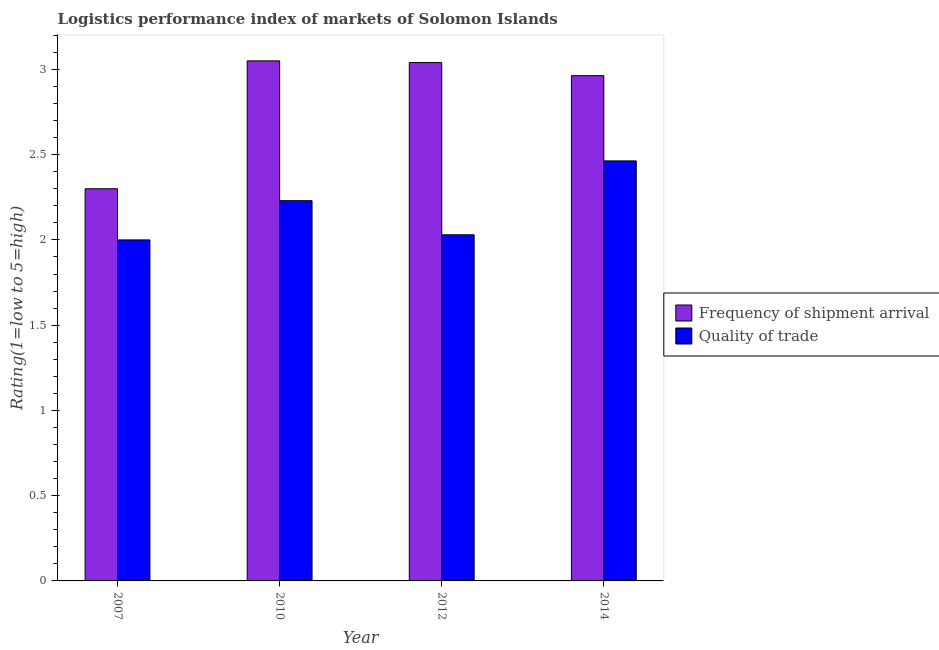How many different coloured bars are there?
Give a very brief answer. 2. Are the number of bars per tick equal to the number of legend labels?
Make the answer very short. Yes. In how many cases, is the number of bars for a given year not equal to the number of legend labels?
Offer a very short reply. 0. What is the lpi of frequency of shipment arrival in 2010?
Your answer should be very brief. 3.05. Across all years, what is the maximum lpi of frequency of shipment arrival?
Offer a terse response. 3.05. In which year was the lpi quality of trade maximum?
Your response must be concise. 2014. What is the total lpi quality of trade in the graph?
Offer a very short reply. 8.72. What is the difference between the lpi quality of trade in 2007 and that in 2010?
Offer a very short reply. -0.23. What is the difference between the lpi of frequency of shipment arrival in 2012 and the lpi quality of trade in 2014?
Your answer should be compact. 0.08. What is the average lpi of frequency of shipment arrival per year?
Ensure brevity in your answer.  2.84. What is the ratio of the lpi quality of trade in 2010 to that in 2012?
Keep it short and to the point. 1.1. Is the lpi of frequency of shipment arrival in 2007 less than that in 2012?
Offer a terse response. Yes. Is the difference between the lpi quality of trade in 2010 and 2012 greater than the difference between the lpi of frequency of shipment arrival in 2010 and 2012?
Your answer should be very brief. No. What is the difference between the highest and the second highest lpi of frequency of shipment arrival?
Make the answer very short. 0.01. What is the difference between the highest and the lowest lpi of frequency of shipment arrival?
Your response must be concise. 0.75. In how many years, is the lpi quality of trade greater than the average lpi quality of trade taken over all years?
Your response must be concise. 2. Is the sum of the lpi quality of trade in 2007 and 2014 greater than the maximum lpi of frequency of shipment arrival across all years?
Your answer should be very brief. Yes. What does the 2nd bar from the left in 2007 represents?
Make the answer very short. Quality of trade. What does the 2nd bar from the right in 2007 represents?
Provide a succinct answer. Frequency of shipment arrival. How many bars are there?
Provide a succinct answer. 8. Are all the bars in the graph horizontal?
Offer a very short reply. No. How many years are there in the graph?
Give a very brief answer. 4. Are the values on the major ticks of Y-axis written in scientific E-notation?
Provide a succinct answer. No. Does the graph contain grids?
Offer a very short reply. No. What is the title of the graph?
Give a very brief answer. Logistics performance index of markets of Solomon Islands. Does "Under-5(female)" appear as one of the legend labels in the graph?
Offer a very short reply. No. What is the label or title of the X-axis?
Provide a short and direct response. Year. What is the label or title of the Y-axis?
Give a very brief answer. Rating(1=low to 5=high). What is the Rating(1=low to 5=high) of Frequency of shipment arrival in 2010?
Keep it short and to the point. 3.05. What is the Rating(1=low to 5=high) in Quality of trade in 2010?
Give a very brief answer. 2.23. What is the Rating(1=low to 5=high) in Frequency of shipment arrival in 2012?
Provide a short and direct response. 3.04. What is the Rating(1=low to 5=high) in Quality of trade in 2012?
Offer a terse response. 2.03. What is the Rating(1=low to 5=high) of Frequency of shipment arrival in 2014?
Provide a short and direct response. 2.96. What is the Rating(1=low to 5=high) in Quality of trade in 2014?
Keep it short and to the point. 2.46. Across all years, what is the maximum Rating(1=low to 5=high) in Frequency of shipment arrival?
Make the answer very short. 3.05. Across all years, what is the maximum Rating(1=low to 5=high) in Quality of trade?
Offer a very short reply. 2.46. Across all years, what is the minimum Rating(1=low to 5=high) in Frequency of shipment arrival?
Keep it short and to the point. 2.3. What is the total Rating(1=low to 5=high) in Frequency of shipment arrival in the graph?
Give a very brief answer. 11.35. What is the total Rating(1=low to 5=high) of Quality of trade in the graph?
Provide a short and direct response. 8.72. What is the difference between the Rating(1=low to 5=high) in Frequency of shipment arrival in 2007 and that in 2010?
Your answer should be compact. -0.75. What is the difference between the Rating(1=low to 5=high) of Quality of trade in 2007 and that in 2010?
Ensure brevity in your answer.  -0.23. What is the difference between the Rating(1=low to 5=high) of Frequency of shipment arrival in 2007 and that in 2012?
Give a very brief answer. -0.74. What is the difference between the Rating(1=low to 5=high) in Quality of trade in 2007 and that in 2012?
Provide a short and direct response. -0.03. What is the difference between the Rating(1=low to 5=high) of Frequency of shipment arrival in 2007 and that in 2014?
Provide a short and direct response. -0.66. What is the difference between the Rating(1=low to 5=high) in Quality of trade in 2007 and that in 2014?
Make the answer very short. -0.46. What is the difference between the Rating(1=low to 5=high) of Frequency of shipment arrival in 2010 and that in 2014?
Keep it short and to the point. 0.09. What is the difference between the Rating(1=low to 5=high) of Quality of trade in 2010 and that in 2014?
Your response must be concise. -0.23. What is the difference between the Rating(1=low to 5=high) in Frequency of shipment arrival in 2012 and that in 2014?
Offer a very short reply. 0.08. What is the difference between the Rating(1=low to 5=high) of Quality of trade in 2012 and that in 2014?
Provide a succinct answer. -0.43. What is the difference between the Rating(1=low to 5=high) of Frequency of shipment arrival in 2007 and the Rating(1=low to 5=high) of Quality of trade in 2010?
Your answer should be compact. 0.07. What is the difference between the Rating(1=low to 5=high) of Frequency of shipment arrival in 2007 and the Rating(1=low to 5=high) of Quality of trade in 2012?
Ensure brevity in your answer.  0.27. What is the difference between the Rating(1=low to 5=high) of Frequency of shipment arrival in 2007 and the Rating(1=low to 5=high) of Quality of trade in 2014?
Your answer should be compact. -0.16. What is the difference between the Rating(1=low to 5=high) in Frequency of shipment arrival in 2010 and the Rating(1=low to 5=high) in Quality of trade in 2014?
Provide a succinct answer. 0.59. What is the difference between the Rating(1=low to 5=high) in Frequency of shipment arrival in 2012 and the Rating(1=low to 5=high) in Quality of trade in 2014?
Offer a terse response. 0.58. What is the average Rating(1=low to 5=high) in Frequency of shipment arrival per year?
Give a very brief answer. 2.84. What is the average Rating(1=low to 5=high) of Quality of trade per year?
Your answer should be compact. 2.18. In the year 2010, what is the difference between the Rating(1=low to 5=high) of Frequency of shipment arrival and Rating(1=low to 5=high) of Quality of trade?
Your answer should be very brief. 0.82. In the year 2012, what is the difference between the Rating(1=low to 5=high) of Frequency of shipment arrival and Rating(1=low to 5=high) of Quality of trade?
Offer a terse response. 1.01. In the year 2014, what is the difference between the Rating(1=low to 5=high) of Frequency of shipment arrival and Rating(1=low to 5=high) of Quality of trade?
Offer a very short reply. 0.5. What is the ratio of the Rating(1=low to 5=high) of Frequency of shipment arrival in 2007 to that in 2010?
Ensure brevity in your answer.  0.75. What is the ratio of the Rating(1=low to 5=high) in Quality of trade in 2007 to that in 2010?
Your answer should be very brief. 0.9. What is the ratio of the Rating(1=low to 5=high) of Frequency of shipment arrival in 2007 to that in 2012?
Provide a succinct answer. 0.76. What is the ratio of the Rating(1=low to 5=high) in Quality of trade in 2007 to that in 2012?
Your response must be concise. 0.99. What is the ratio of the Rating(1=low to 5=high) of Frequency of shipment arrival in 2007 to that in 2014?
Your answer should be compact. 0.78. What is the ratio of the Rating(1=low to 5=high) of Quality of trade in 2007 to that in 2014?
Make the answer very short. 0.81. What is the ratio of the Rating(1=low to 5=high) of Quality of trade in 2010 to that in 2012?
Make the answer very short. 1.1. What is the ratio of the Rating(1=low to 5=high) in Frequency of shipment arrival in 2010 to that in 2014?
Provide a succinct answer. 1.03. What is the ratio of the Rating(1=low to 5=high) in Quality of trade in 2010 to that in 2014?
Your answer should be compact. 0.91. What is the ratio of the Rating(1=low to 5=high) of Frequency of shipment arrival in 2012 to that in 2014?
Provide a succinct answer. 1.03. What is the ratio of the Rating(1=low to 5=high) in Quality of trade in 2012 to that in 2014?
Your answer should be compact. 0.82. What is the difference between the highest and the second highest Rating(1=low to 5=high) of Quality of trade?
Your answer should be very brief. 0.23. What is the difference between the highest and the lowest Rating(1=low to 5=high) of Frequency of shipment arrival?
Make the answer very short. 0.75. What is the difference between the highest and the lowest Rating(1=low to 5=high) in Quality of trade?
Your response must be concise. 0.46. 